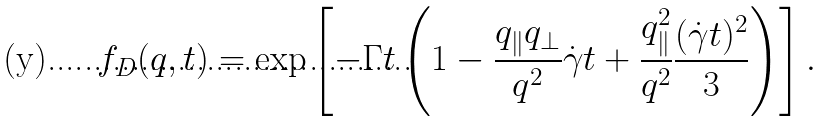Convert formula to latex. <formula><loc_0><loc_0><loc_500><loc_500>f _ { D } ( { q } , t ) = \exp \left [ - \Gamma t \left ( 1 - \frac { q _ { \| } q _ { \perp } } { q ^ { 2 } } \dot { \gamma } t + \frac { q _ { \| } ^ { 2 } } { q ^ { 2 } } \frac { ( \dot { \gamma } t ) ^ { 2 } } { 3 } \right ) \right ] .</formula> 